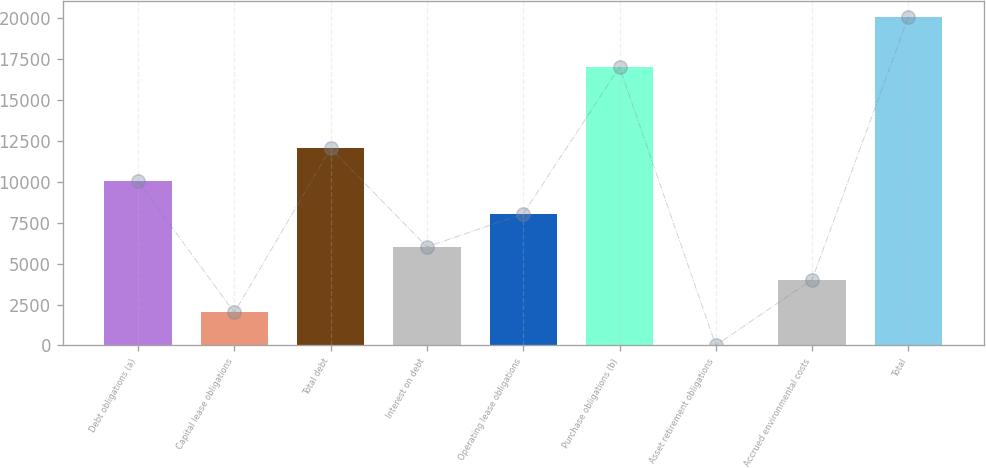<chart> <loc_0><loc_0><loc_500><loc_500><bar_chart><fcel>Debt obligations (a)<fcel>Capital lease obligations<fcel>Total debt<fcel>Interest on debt<fcel>Operating lease obligations<fcel>Purchase obligations (b)<fcel>Asset retirement obligations<fcel>Accrued environmental costs<fcel>Total<nl><fcel>10049<fcel>2017.8<fcel>12056.8<fcel>6033.4<fcel>8041.2<fcel>17023<fcel>10<fcel>4025.6<fcel>20088<nl></chart> 